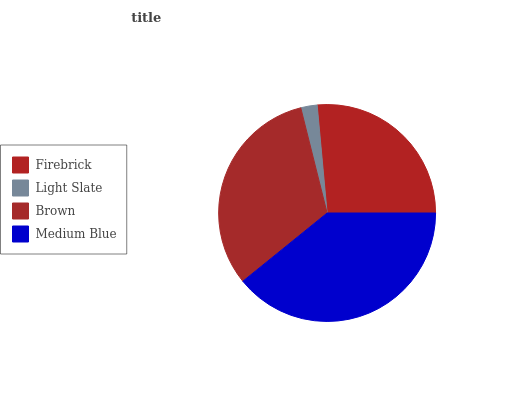Is Light Slate the minimum?
Answer yes or no. Yes. Is Medium Blue the maximum?
Answer yes or no. Yes. Is Brown the minimum?
Answer yes or no. No. Is Brown the maximum?
Answer yes or no. No. Is Brown greater than Light Slate?
Answer yes or no. Yes. Is Light Slate less than Brown?
Answer yes or no. Yes. Is Light Slate greater than Brown?
Answer yes or no. No. Is Brown less than Light Slate?
Answer yes or no. No. Is Brown the high median?
Answer yes or no. Yes. Is Firebrick the low median?
Answer yes or no. Yes. Is Firebrick the high median?
Answer yes or no. No. Is Brown the low median?
Answer yes or no. No. 